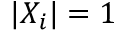<formula> <loc_0><loc_0><loc_500><loc_500>| X _ { i } | = 1</formula> 